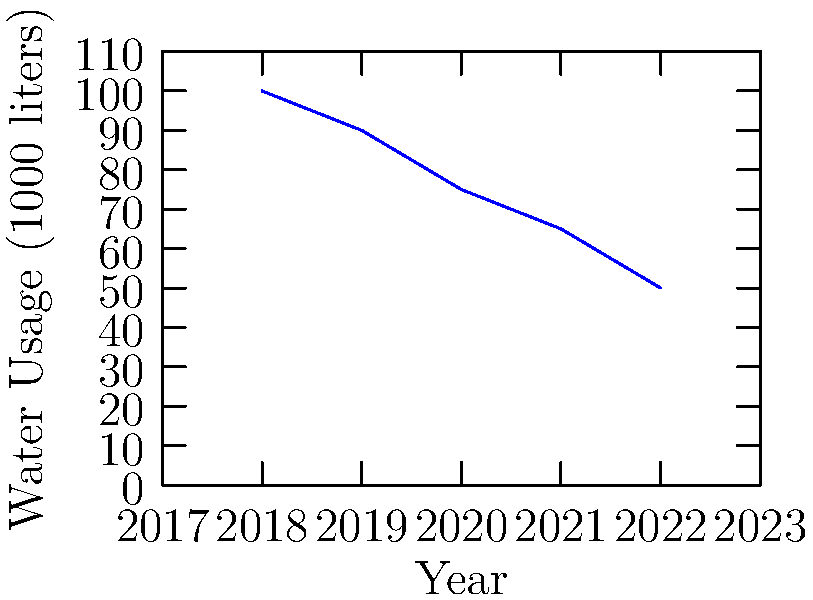As a conscious consumer supporting sustainable brands, you're analyzing a line graph showing the reduction in water usage by a clothing manufacturer. What was the approximate percentage decrease in water usage from 2018 to 2022? To calculate the percentage decrease in water usage from 2018 to 2022, we'll follow these steps:

1. Identify the water usage values:
   - 2018: 100,000 liters
   - 2022: 50,000 liters

2. Calculate the decrease in water usage:
   $100,000 - 50,000 = 50,000$ liters

3. Calculate the percentage decrease:
   Percentage decrease = $\frac{\text{Decrease}}{\text{Original Value}} \times 100\%$
   
   $= \frac{50,000}{100,000} \times 100\%$
   $= 0.5 \times 100\%$
   $= 50\%$

Therefore, the water usage decreased by approximately 50% from 2018 to 2022.
Answer: 50% 